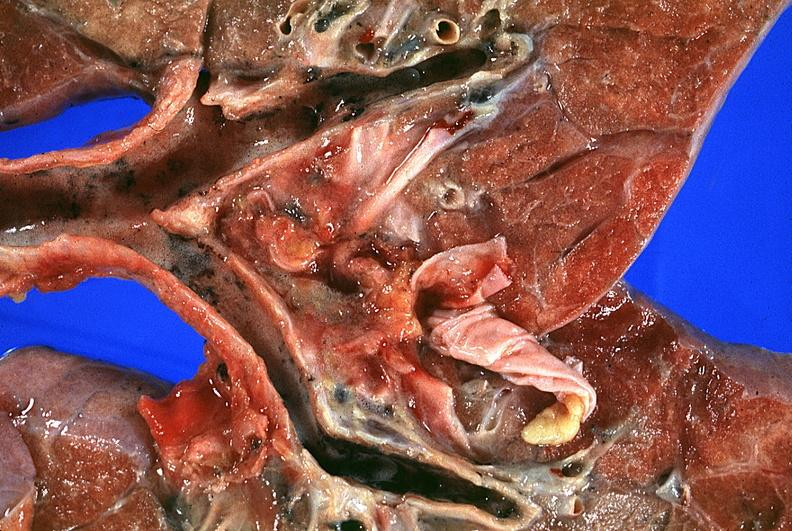s corpus luteum present?
Answer the question using a single word or phrase. No 